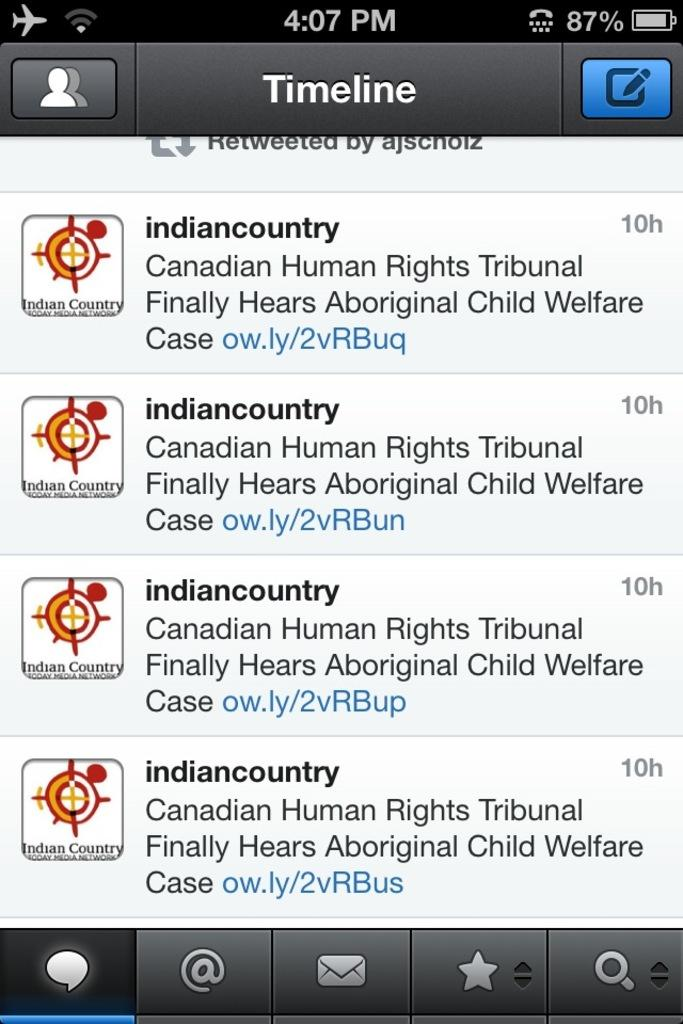<image>
Give a short and clear explanation of the subsequent image. A Twitter feed orlie thing is shown with messages about Canadian Human Rights Tribunal news 